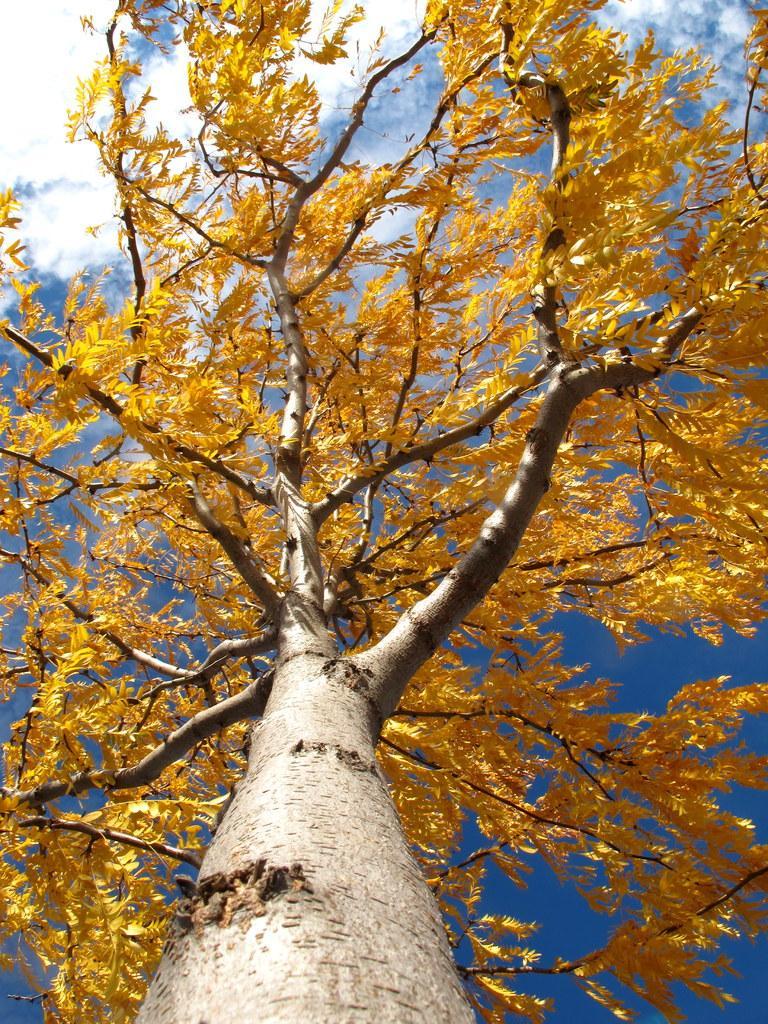Could you give a brief overview of what you see in this image? In this image we can see a tree and in the background, we can see the sky with clouds. 